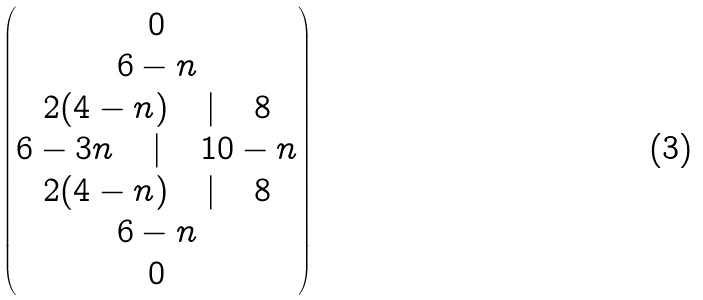<formula> <loc_0><loc_0><loc_500><loc_500>\begin{pmatrix} 0 \\ 6 - n \\ 2 ( 4 - n ) \quad | \quad 8 \\ 6 - 3 n \quad | \quad 1 0 - n \\ 2 ( 4 - n ) \quad | \quad 8 \\ 6 - n \\ 0 \end{pmatrix}</formula> 